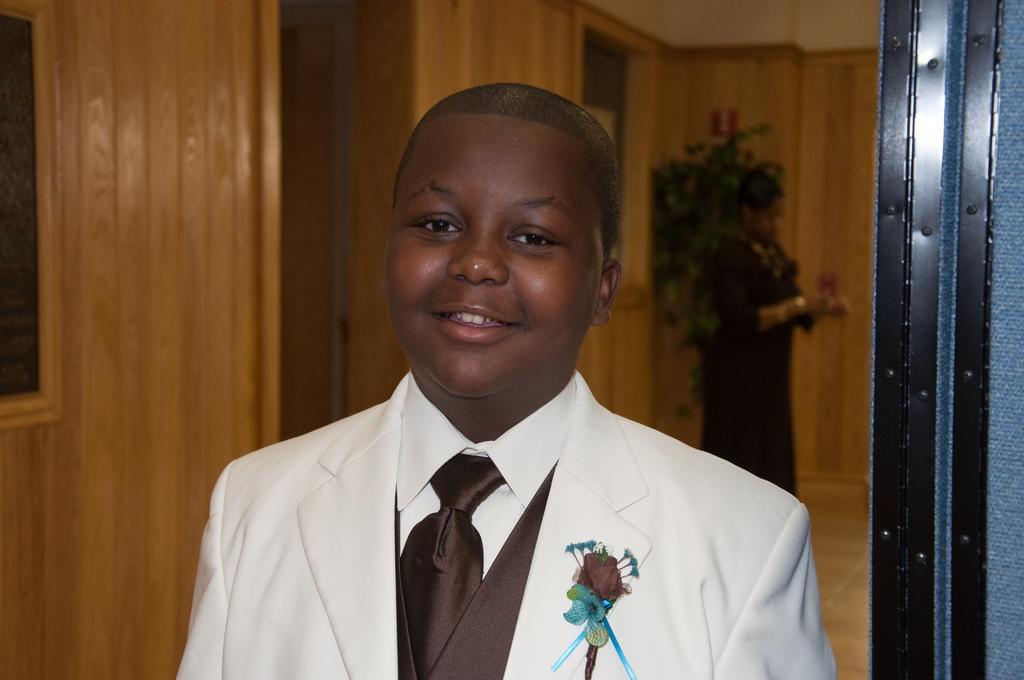Could you give a brief overview of what you see in this image? Here we can see a person. He is smiling and he is in a suit. In the background we can see a person standing on the floor and this is wall. 